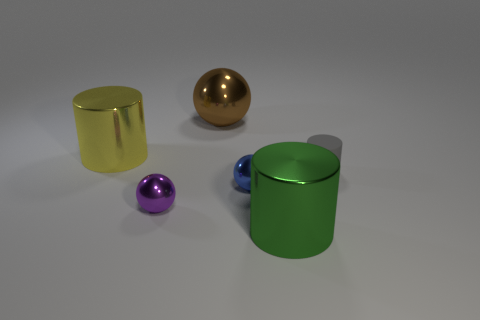Add 2 tiny purple rubber cylinders. How many objects exist? 8 Subtract 0 cyan cylinders. How many objects are left? 6 Subtract all large purple metal cubes. Subtract all blue metallic balls. How many objects are left? 5 Add 4 big yellow metallic objects. How many big yellow metallic objects are left? 5 Add 1 large yellow metallic things. How many large yellow metallic things exist? 2 